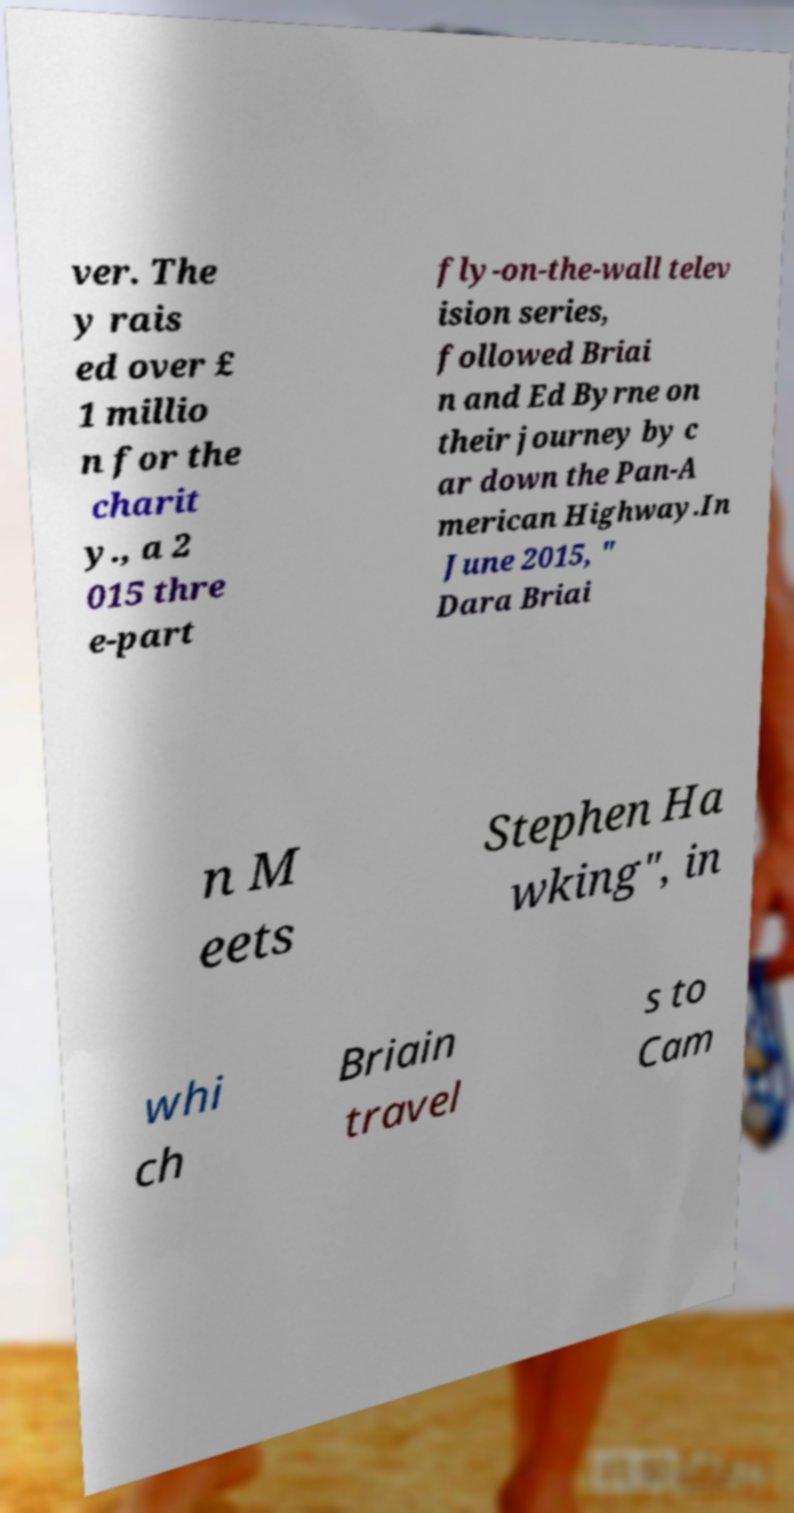For documentation purposes, I need the text within this image transcribed. Could you provide that? ver. The y rais ed over £ 1 millio n for the charit y., a 2 015 thre e-part fly-on-the-wall telev ision series, followed Briai n and Ed Byrne on their journey by c ar down the Pan-A merican Highway.In June 2015, " Dara Briai n M eets Stephen Ha wking", in whi ch Briain travel s to Cam 